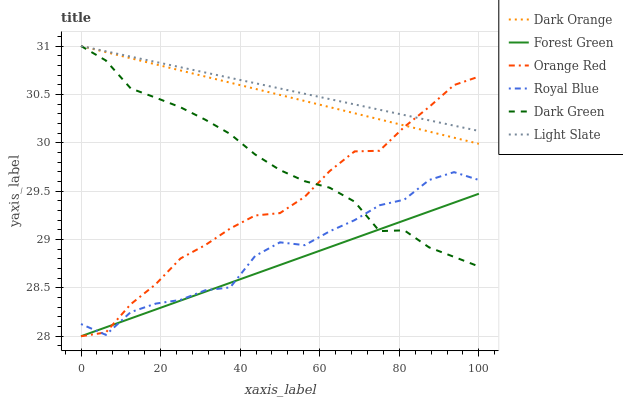Does Forest Green have the minimum area under the curve?
Answer yes or no. Yes. Does Light Slate have the maximum area under the curve?
Answer yes or no. Yes. Does Royal Blue have the minimum area under the curve?
Answer yes or no. No. Does Royal Blue have the maximum area under the curve?
Answer yes or no. No. Is Light Slate the smoothest?
Answer yes or no. Yes. Is Royal Blue the roughest?
Answer yes or no. Yes. Is Royal Blue the smoothest?
Answer yes or no. No. Is Light Slate the roughest?
Answer yes or no. No. Does Forest Green have the lowest value?
Answer yes or no. Yes. Does Royal Blue have the lowest value?
Answer yes or no. No. Does Dark Green have the highest value?
Answer yes or no. Yes. Does Royal Blue have the highest value?
Answer yes or no. No. Is Royal Blue less than Light Slate?
Answer yes or no. Yes. Is Light Slate greater than Royal Blue?
Answer yes or no. Yes. Does Dark Green intersect Forest Green?
Answer yes or no. Yes. Is Dark Green less than Forest Green?
Answer yes or no. No. Is Dark Green greater than Forest Green?
Answer yes or no. No. Does Royal Blue intersect Light Slate?
Answer yes or no. No. 